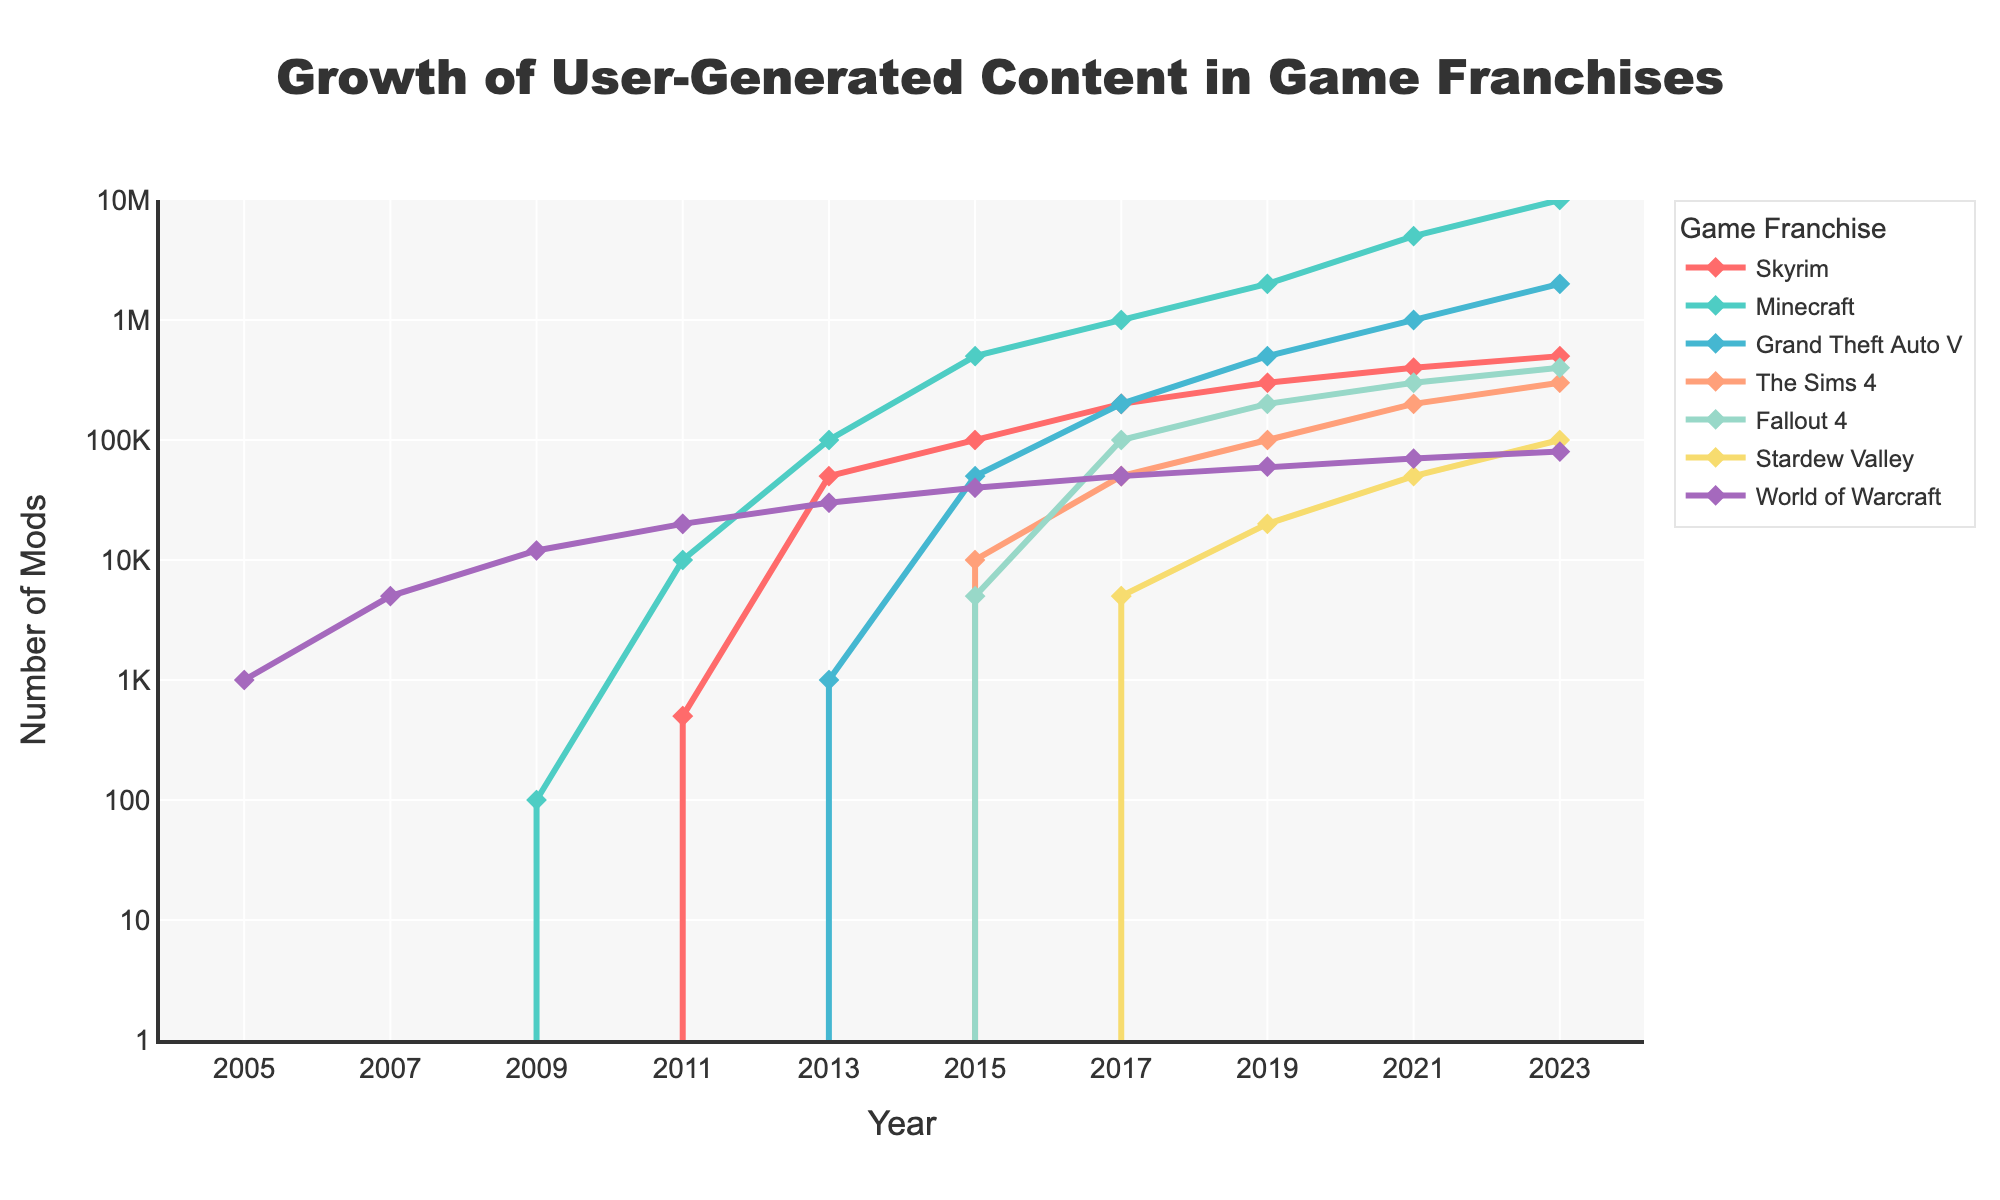Which game franchise had the highest number of mods in 2023? Look at the 2023 data points for all franchises and compare them. Minecraft has the highest value with 10,000,000 mods.
Answer: Minecraft Which franchise saw the most significant growth in mods from 2005 to 2023? Compare the difference in the number of mods in 2023 and 2005 for each franchise. Minecraft grew from 0 in 2005 to 10,000,000 in 2023, marking the most significant growth.
Answer: Minecraft By how much did the number of mods for Fallout 4 increase from 2015 to 2021? Find the values for Fallout 4 in 2015 and 2021, then subtract the former from the latter. Values are 5,000 in 2015 and 300,000 in 2021. The increase is 300,000 - 5,000 = 295,000.
Answer: 295,000 Which game franchise had the smallest increase in the number of mods between 2007 and 2017? Check the increase in mods for each franchise by subtracting values from 2007 and 2017. World of Warcraft had an increase from 5,000 to 50,000, showing an increase of 45,000, which is the smallest among the options.
Answer: World of Warcraft Compare the number of mods for Skyrim and Grand Theft Auto V in 2021. Which one had more and by how much? Check the values for both franchises in 2021. Skyrim had 400,000 mods, and Grand Theft Auto V had 1,000,000. The difference is 1,000,000 - 400,000 = 600,000.
Answer: Grand Theft Auto V, 600,000 What is the average number of mods for Stardew Valley from 2015 to 2023 based on the data provided? Sum the number of mods for Stardew Valley from 2015, 2017, 2019, 2021, and 2023. Values are 0, 5,000, 20,000, 50,000, 100,000. Average is (0 + 5,000 + 20,000 + 50,000 + 100,000) / 5 = 35,000.
Answer: 35,000 Between 2019 and 2023, which franchise experienced the highest relative growth in mods? Calculate the relative growth for each franchise between 2019 and 2023. Minecraft grows from 2,000,000 to 10,000,000. Relative growth is (10,000,000 - 2,000,000) / 2,000,000 = 4.
Answer: Minecraft Which game franchise had no mods until 2015 but saw significant growth afterward? Refer to values before and after 2015 for each franchise. The Sims 4 had 0 mods until 2015 and then increased to 10,000 in 2015 and beyond.
Answer: The Sims 4 How did the number of mods for World of Warcraft change from 2005 to 2023? Compare the values of World of Warcraft in 2005 and 2023. The numbers are 1,000 in 2005 and 80,000 in 2023. Change is 80,000 - 1,000 = 79,000.
Answer: Increased by 79,000 If Skyrim, Minecraft, and Stardew Valley form a group, what's their combined number of mods in 2017? Add the number of mods for Skyrim (200,000), Minecraft (1,000,000), and Stardew Valley (5,000) in 2017. Combined mods are 200,000 + 1,000,000 + 5,000 = 1,205,000.
Answer: 1,205,000 